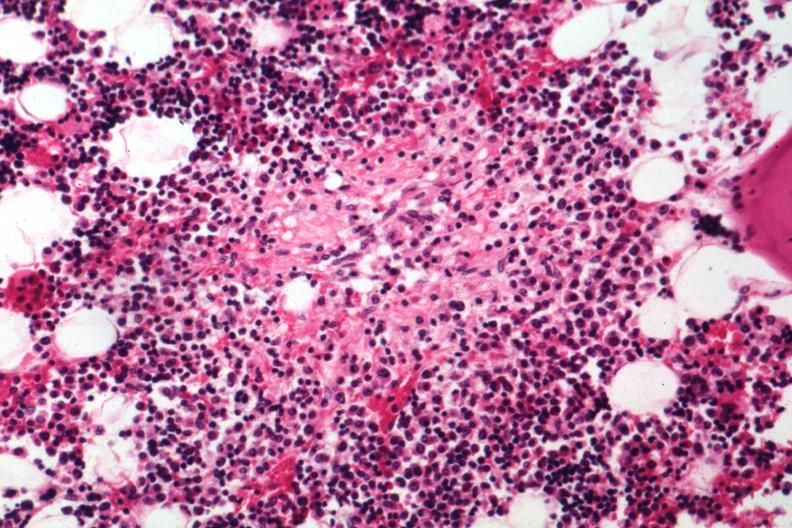s close-up excellent example of interosseous muscle atrophy present?
Answer the question using a single word or phrase. No 